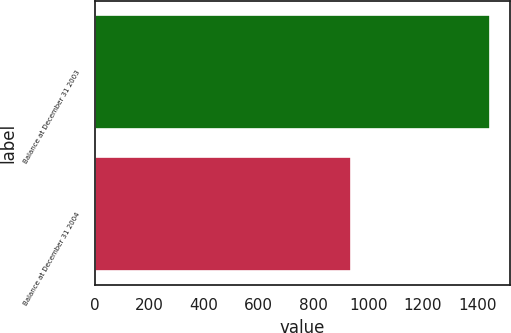<chart> <loc_0><loc_0><loc_500><loc_500><bar_chart><fcel>Balance at December 31 2003<fcel>Balance at December 31 2004<nl><fcel>1447<fcel>938<nl></chart> 